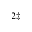Convert formula to latex. <formula><loc_0><loc_0><loc_500><loc_500>^ { 2 \ddagger }</formula> 